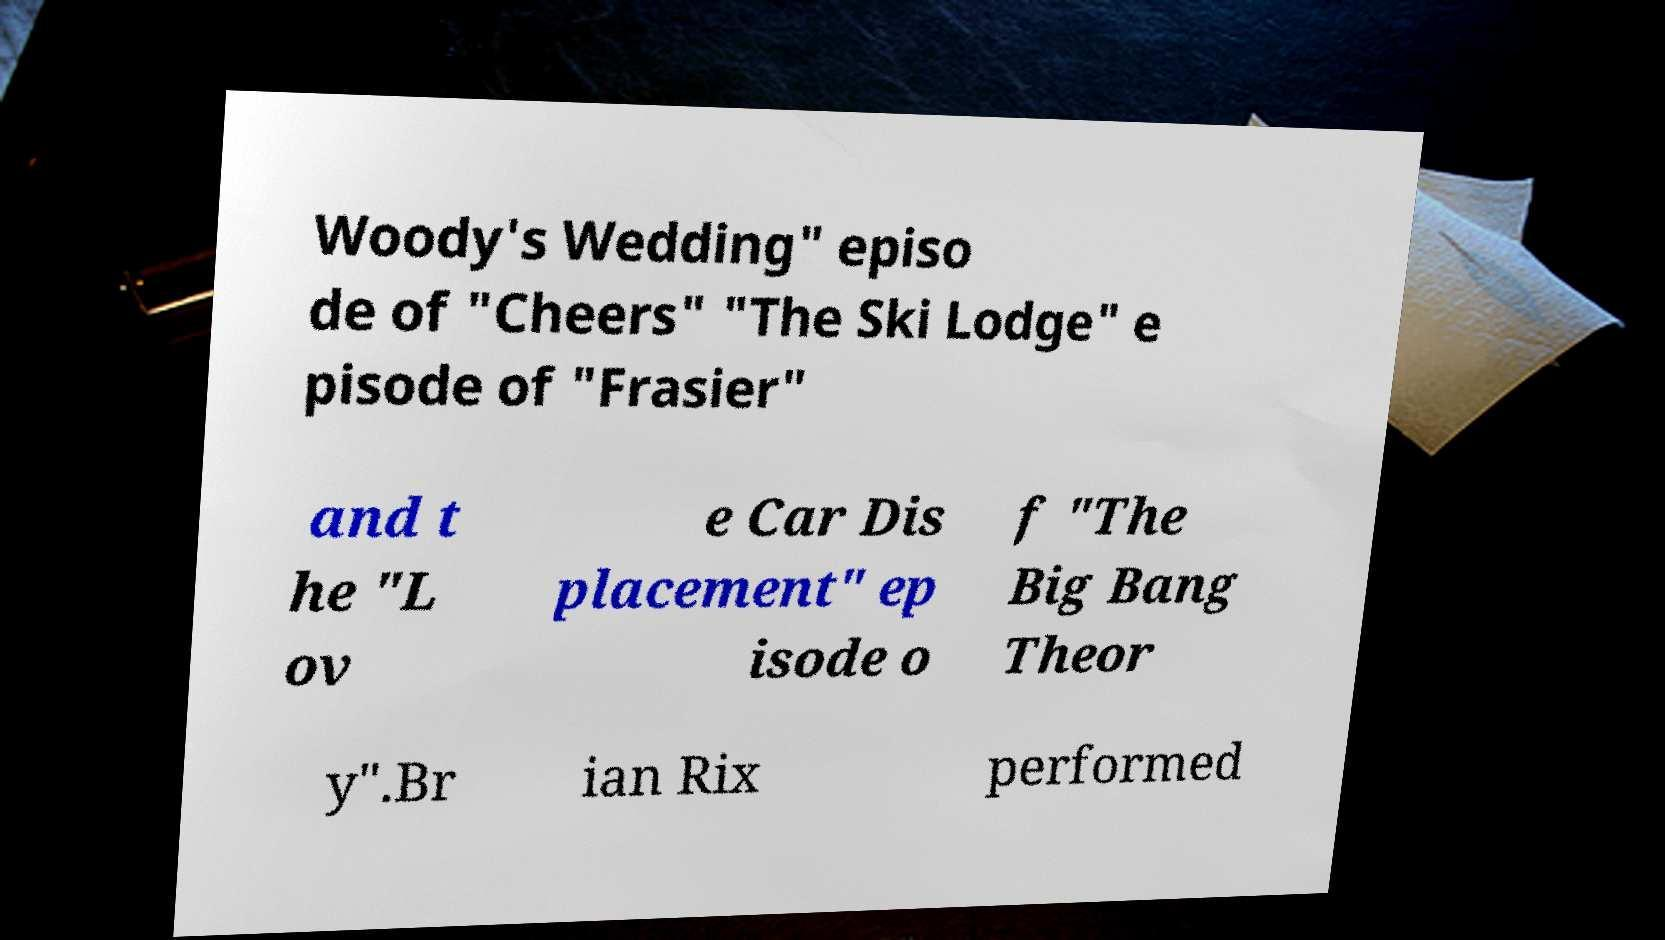Could you assist in decoding the text presented in this image and type it out clearly? Woody's Wedding" episo de of "Cheers" "The Ski Lodge" e pisode of "Frasier" and t he "L ov e Car Dis placement" ep isode o f "The Big Bang Theor y".Br ian Rix performed 